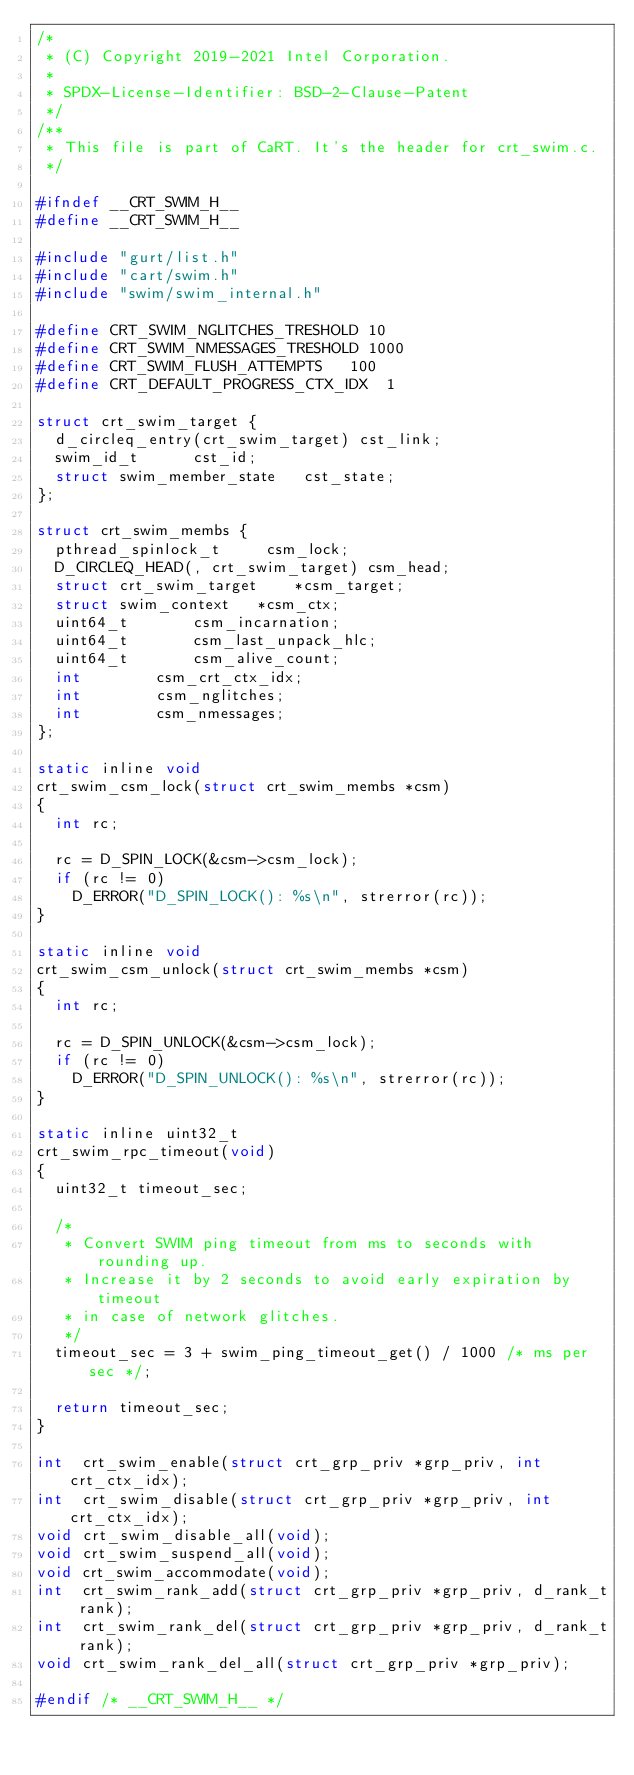Convert code to text. <code><loc_0><loc_0><loc_500><loc_500><_C_>/*
 * (C) Copyright 2019-2021 Intel Corporation.
 *
 * SPDX-License-Identifier: BSD-2-Clause-Patent
 */
/**
 * This file is part of CaRT. It's the header for crt_swim.c.
 */

#ifndef __CRT_SWIM_H__
#define __CRT_SWIM_H__

#include "gurt/list.h"
#include "cart/swim.h"
#include "swim/swim_internal.h"

#define CRT_SWIM_NGLITCHES_TRESHOLD	10
#define CRT_SWIM_NMESSAGES_TRESHOLD	1000
#define CRT_SWIM_FLUSH_ATTEMPTS		100
#define CRT_DEFAULT_PROGRESS_CTX_IDX	1

struct crt_swim_target {
	d_circleq_entry(crt_swim_target) cst_link;
	swim_id_t			 cst_id;
	struct swim_member_state	 cst_state;
};

struct crt_swim_membs {
	pthread_spinlock_t		 csm_lock;
	D_CIRCLEQ_HEAD(, crt_swim_target) csm_head;
	struct crt_swim_target		*csm_target;
	struct swim_context		*csm_ctx;
	uint64_t			 csm_incarnation;
	uint64_t			 csm_last_unpack_hlc;
	uint64_t			 csm_alive_count;
	int				 csm_crt_ctx_idx;
	int				 csm_nglitches;
	int				 csm_nmessages;
};

static inline void
crt_swim_csm_lock(struct crt_swim_membs *csm)
{
	int rc;

	rc = D_SPIN_LOCK(&csm->csm_lock);
	if (rc != 0)
		D_ERROR("D_SPIN_LOCK(): %s\n", strerror(rc));
}

static inline void
crt_swim_csm_unlock(struct crt_swim_membs *csm)
{
	int rc;

	rc = D_SPIN_UNLOCK(&csm->csm_lock);
	if (rc != 0)
		D_ERROR("D_SPIN_UNLOCK(): %s\n", strerror(rc));
}

static inline uint32_t
crt_swim_rpc_timeout(void)
{
	uint32_t timeout_sec;

	/*
	 * Convert SWIM ping timeout from ms to seconds with rounding up.
	 * Increase it by 2 seconds to avoid early expiration by timeout
	 * in case of network glitches.
	 */
	timeout_sec = 3 + swim_ping_timeout_get() / 1000 /* ms per sec */;

	return timeout_sec;
}

int  crt_swim_enable(struct crt_grp_priv *grp_priv, int crt_ctx_idx);
int  crt_swim_disable(struct crt_grp_priv *grp_priv, int crt_ctx_idx);
void crt_swim_disable_all(void);
void crt_swim_suspend_all(void);
void crt_swim_accommodate(void);
int  crt_swim_rank_add(struct crt_grp_priv *grp_priv, d_rank_t rank);
int  crt_swim_rank_del(struct crt_grp_priv *grp_priv, d_rank_t rank);
void crt_swim_rank_del_all(struct crt_grp_priv *grp_priv);

#endif /* __CRT_SWIM_H__ */
</code> 